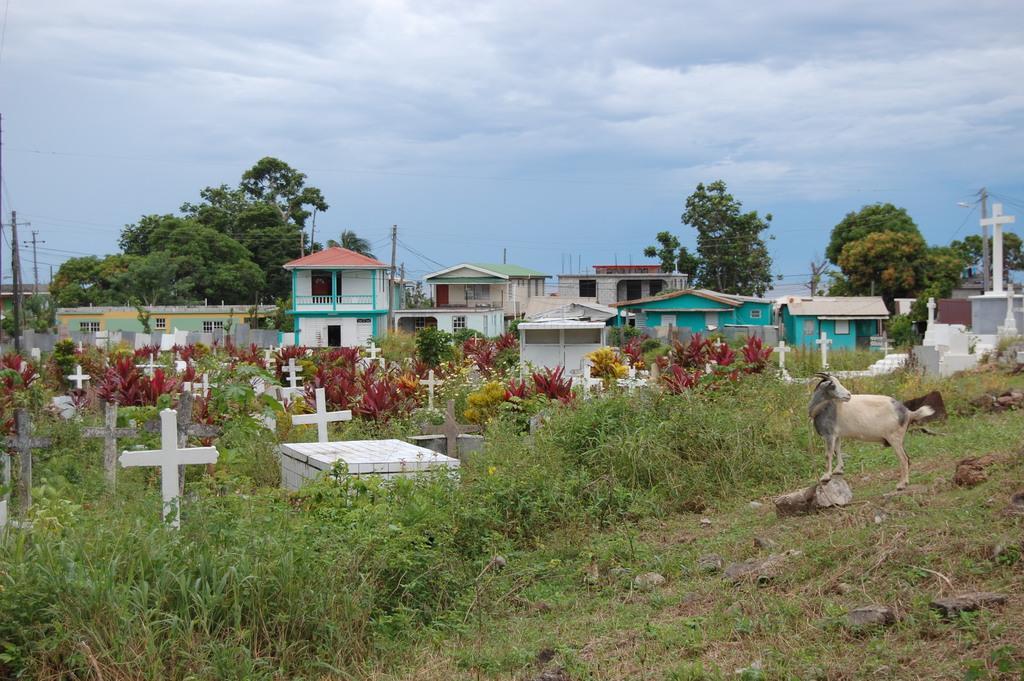How would you summarize this image in a sentence or two? In this image we can see the cross grave stones, an animal, few rocks, houses with the windows, trees, grass, plants, transmission towers, at the top we can see the sky with clouds. 